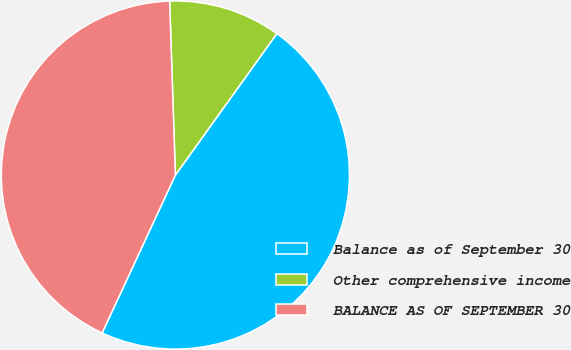Convert chart. <chart><loc_0><loc_0><loc_500><loc_500><pie_chart><fcel>Balance as of September 30<fcel>Other comprehensive income<fcel>BALANCE AS OF SEPTEMBER 30<nl><fcel>47.01%<fcel>10.43%<fcel>42.56%<nl></chart> 